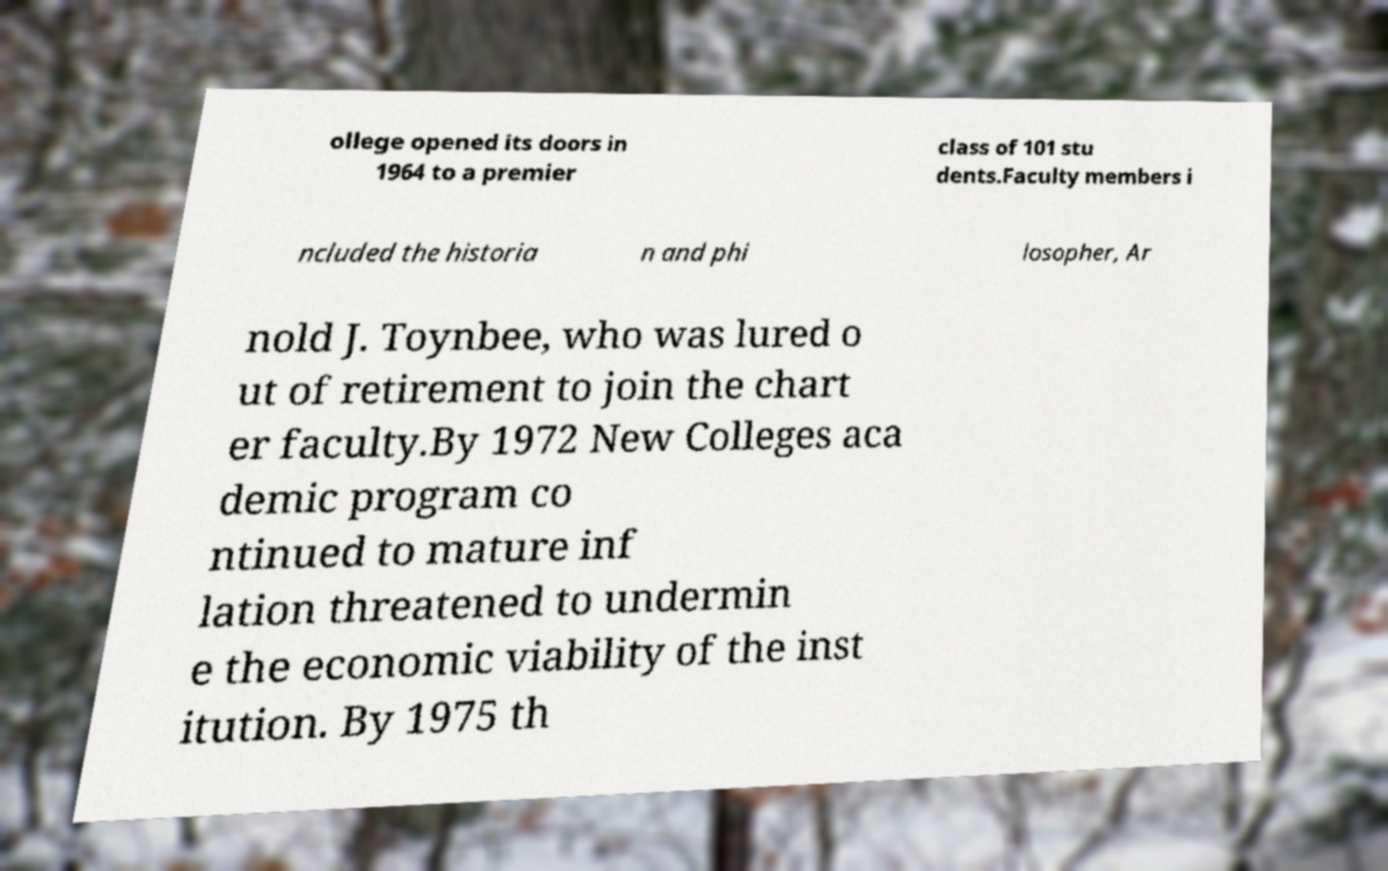I need the written content from this picture converted into text. Can you do that? ollege opened its doors in 1964 to a premier class of 101 stu dents.Faculty members i ncluded the historia n and phi losopher, Ar nold J. Toynbee, who was lured o ut of retirement to join the chart er faculty.By 1972 New Colleges aca demic program co ntinued to mature inf lation threatened to undermin e the economic viability of the inst itution. By 1975 th 